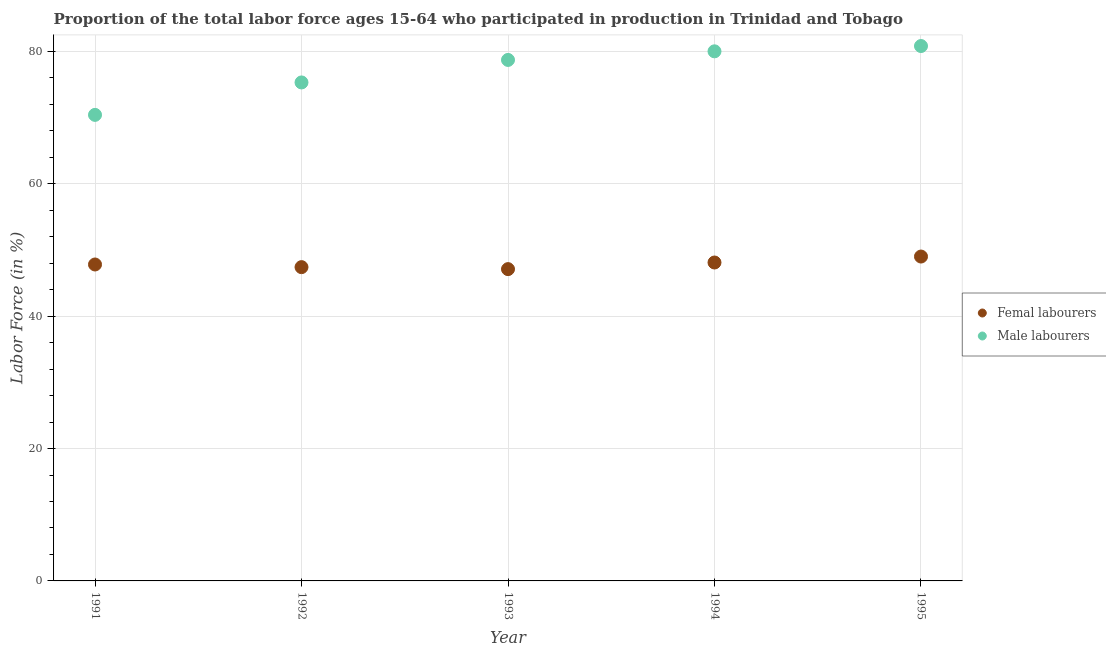Is the number of dotlines equal to the number of legend labels?
Give a very brief answer. Yes. What is the percentage of female labor force in 1995?
Your answer should be very brief. 49. Across all years, what is the maximum percentage of male labour force?
Provide a succinct answer. 80.8. Across all years, what is the minimum percentage of female labor force?
Your answer should be very brief. 47.1. In which year was the percentage of male labour force maximum?
Your response must be concise. 1995. In which year was the percentage of female labor force minimum?
Keep it short and to the point. 1993. What is the total percentage of male labour force in the graph?
Provide a short and direct response. 385.2. What is the difference between the percentage of male labour force in 1991 and that in 1994?
Give a very brief answer. -9.6. What is the difference between the percentage of male labour force in 1991 and the percentage of female labor force in 1995?
Offer a terse response. 21.4. What is the average percentage of male labour force per year?
Provide a short and direct response. 77.04. In the year 1995, what is the difference between the percentage of male labour force and percentage of female labor force?
Provide a succinct answer. 31.8. What is the ratio of the percentage of female labor force in 1992 to that in 1993?
Make the answer very short. 1.01. What is the difference between the highest and the second highest percentage of male labour force?
Your response must be concise. 0.8. What is the difference between the highest and the lowest percentage of female labor force?
Make the answer very short. 1.9. Does the percentage of female labor force monotonically increase over the years?
Keep it short and to the point. No. Is the percentage of male labour force strictly greater than the percentage of female labor force over the years?
Provide a short and direct response. Yes. How many years are there in the graph?
Provide a succinct answer. 5. What is the difference between two consecutive major ticks on the Y-axis?
Provide a succinct answer. 20. Are the values on the major ticks of Y-axis written in scientific E-notation?
Offer a terse response. No. Where does the legend appear in the graph?
Offer a very short reply. Center right. How many legend labels are there?
Ensure brevity in your answer.  2. What is the title of the graph?
Your answer should be compact. Proportion of the total labor force ages 15-64 who participated in production in Trinidad and Tobago. Does "Male labor force" appear as one of the legend labels in the graph?
Your response must be concise. No. What is the label or title of the Y-axis?
Your answer should be compact. Labor Force (in %). What is the Labor Force (in %) of Femal labourers in 1991?
Offer a very short reply. 47.8. What is the Labor Force (in %) in Male labourers in 1991?
Give a very brief answer. 70.4. What is the Labor Force (in %) of Femal labourers in 1992?
Give a very brief answer. 47.4. What is the Labor Force (in %) of Male labourers in 1992?
Your response must be concise. 75.3. What is the Labor Force (in %) in Femal labourers in 1993?
Provide a short and direct response. 47.1. What is the Labor Force (in %) of Male labourers in 1993?
Give a very brief answer. 78.7. What is the Labor Force (in %) of Femal labourers in 1994?
Keep it short and to the point. 48.1. What is the Labor Force (in %) of Male labourers in 1995?
Ensure brevity in your answer.  80.8. Across all years, what is the maximum Labor Force (in %) of Femal labourers?
Your answer should be compact. 49. Across all years, what is the maximum Labor Force (in %) of Male labourers?
Ensure brevity in your answer.  80.8. Across all years, what is the minimum Labor Force (in %) of Femal labourers?
Provide a short and direct response. 47.1. Across all years, what is the minimum Labor Force (in %) in Male labourers?
Give a very brief answer. 70.4. What is the total Labor Force (in %) of Femal labourers in the graph?
Provide a succinct answer. 239.4. What is the total Labor Force (in %) in Male labourers in the graph?
Your answer should be very brief. 385.2. What is the difference between the Labor Force (in %) in Femal labourers in 1991 and that in 1992?
Offer a very short reply. 0.4. What is the difference between the Labor Force (in %) in Male labourers in 1991 and that in 1992?
Your answer should be very brief. -4.9. What is the difference between the Labor Force (in %) in Femal labourers in 1991 and that in 1993?
Keep it short and to the point. 0.7. What is the difference between the Labor Force (in %) in Femal labourers in 1991 and that in 1994?
Your answer should be compact. -0.3. What is the difference between the Labor Force (in %) in Male labourers in 1991 and that in 1994?
Keep it short and to the point. -9.6. What is the difference between the Labor Force (in %) in Femal labourers in 1991 and that in 1995?
Provide a succinct answer. -1.2. What is the difference between the Labor Force (in %) of Male labourers in 1991 and that in 1995?
Your answer should be compact. -10.4. What is the difference between the Labor Force (in %) of Femal labourers in 1992 and that in 1993?
Offer a very short reply. 0.3. What is the difference between the Labor Force (in %) of Male labourers in 1992 and that in 1993?
Offer a terse response. -3.4. What is the difference between the Labor Force (in %) in Femal labourers in 1992 and that in 1994?
Offer a very short reply. -0.7. What is the difference between the Labor Force (in %) of Male labourers in 1992 and that in 1994?
Offer a terse response. -4.7. What is the difference between the Labor Force (in %) in Male labourers in 1992 and that in 1995?
Your response must be concise. -5.5. What is the difference between the Labor Force (in %) of Male labourers in 1993 and that in 1995?
Offer a terse response. -2.1. What is the difference between the Labor Force (in %) of Male labourers in 1994 and that in 1995?
Make the answer very short. -0.8. What is the difference between the Labor Force (in %) of Femal labourers in 1991 and the Labor Force (in %) of Male labourers in 1992?
Ensure brevity in your answer.  -27.5. What is the difference between the Labor Force (in %) of Femal labourers in 1991 and the Labor Force (in %) of Male labourers in 1993?
Ensure brevity in your answer.  -30.9. What is the difference between the Labor Force (in %) in Femal labourers in 1991 and the Labor Force (in %) in Male labourers in 1994?
Your answer should be very brief. -32.2. What is the difference between the Labor Force (in %) in Femal labourers in 1991 and the Labor Force (in %) in Male labourers in 1995?
Provide a succinct answer. -33. What is the difference between the Labor Force (in %) of Femal labourers in 1992 and the Labor Force (in %) of Male labourers in 1993?
Make the answer very short. -31.3. What is the difference between the Labor Force (in %) of Femal labourers in 1992 and the Labor Force (in %) of Male labourers in 1994?
Provide a succinct answer. -32.6. What is the difference between the Labor Force (in %) in Femal labourers in 1992 and the Labor Force (in %) in Male labourers in 1995?
Provide a succinct answer. -33.4. What is the difference between the Labor Force (in %) in Femal labourers in 1993 and the Labor Force (in %) in Male labourers in 1994?
Offer a very short reply. -32.9. What is the difference between the Labor Force (in %) of Femal labourers in 1993 and the Labor Force (in %) of Male labourers in 1995?
Keep it short and to the point. -33.7. What is the difference between the Labor Force (in %) in Femal labourers in 1994 and the Labor Force (in %) in Male labourers in 1995?
Provide a succinct answer. -32.7. What is the average Labor Force (in %) of Femal labourers per year?
Give a very brief answer. 47.88. What is the average Labor Force (in %) of Male labourers per year?
Your answer should be very brief. 77.04. In the year 1991, what is the difference between the Labor Force (in %) of Femal labourers and Labor Force (in %) of Male labourers?
Provide a succinct answer. -22.6. In the year 1992, what is the difference between the Labor Force (in %) of Femal labourers and Labor Force (in %) of Male labourers?
Your answer should be very brief. -27.9. In the year 1993, what is the difference between the Labor Force (in %) in Femal labourers and Labor Force (in %) in Male labourers?
Offer a very short reply. -31.6. In the year 1994, what is the difference between the Labor Force (in %) in Femal labourers and Labor Force (in %) in Male labourers?
Offer a terse response. -31.9. In the year 1995, what is the difference between the Labor Force (in %) in Femal labourers and Labor Force (in %) in Male labourers?
Offer a terse response. -31.8. What is the ratio of the Labor Force (in %) in Femal labourers in 1991 to that in 1992?
Your answer should be very brief. 1.01. What is the ratio of the Labor Force (in %) of Male labourers in 1991 to that in 1992?
Your response must be concise. 0.93. What is the ratio of the Labor Force (in %) of Femal labourers in 1991 to that in 1993?
Offer a very short reply. 1.01. What is the ratio of the Labor Force (in %) in Male labourers in 1991 to that in 1993?
Your answer should be compact. 0.89. What is the ratio of the Labor Force (in %) in Male labourers in 1991 to that in 1994?
Make the answer very short. 0.88. What is the ratio of the Labor Force (in %) in Femal labourers in 1991 to that in 1995?
Give a very brief answer. 0.98. What is the ratio of the Labor Force (in %) of Male labourers in 1991 to that in 1995?
Provide a succinct answer. 0.87. What is the ratio of the Labor Force (in %) in Femal labourers in 1992 to that in 1993?
Give a very brief answer. 1.01. What is the ratio of the Labor Force (in %) in Male labourers in 1992 to that in 1993?
Ensure brevity in your answer.  0.96. What is the ratio of the Labor Force (in %) in Femal labourers in 1992 to that in 1994?
Offer a very short reply. 0.99. What is the ratio of the Labor Force (in %) of Male labourers in 1992 to that in 1994?
Provide a short and direct response. 0.94. What is the ratio of the Labor Force (in %) of Femal labourers in 1992 to that in 1995?
Your answer should be compact. 0.97. What is the ratio of the Labor Force (in %) in Male labourers in 1992 to that in 1995?
Provide a succinct answer. 0.93. What is the ratio of the Labor Force (in %) of Femal labourers in 1993 to that in 1994?
Offer a very short reply. 0.98. What is the ratio of the Labor Force (in %) of Male labourers in 1993 to that in 1994?
Provide a short and direct response. 0.98. What is the ratio of the Labor Force (in %) in Femal labourers in 1993 to that in 1995?
Your answer should be compact. 0.96. What is the ratio of the Labor Force (in %) of Femal labourers in 1994 to that in 1995?
Make the answer very short. 0.98. What is the ratio of the Labor Force (in %) in Male labourers in 1994 to that in 1995?
Keep it short and to the point. 0.99. What is the difference between the highest and the second highest Labor Force (in %) of Femal labourers?
Keep it short and to the point. 0.9. What is the difference between the highest and the lowest Labor Force (in %) of Femal labourers?
Provide a short and direct response. 1.9. What is the difference between the highest and the lowest Labor Force (in %) of Male labourers?
Keep it short and to the point. 10.4. 